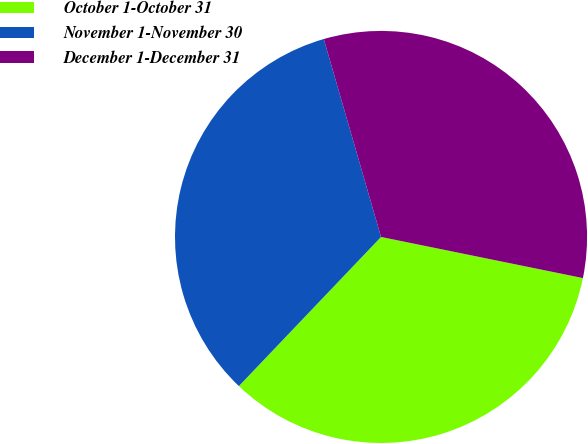Convert chart to OTSL. <chart><loc_0><loc_0><loc_500><loc_500><pie_chart><fcel>October 1-October 31<fcel>November 1-November 30<fcel>December 1-December 31<nl><fcel>33.92%<fcel>33.4%<fcel>32.68%<nl></chart> 